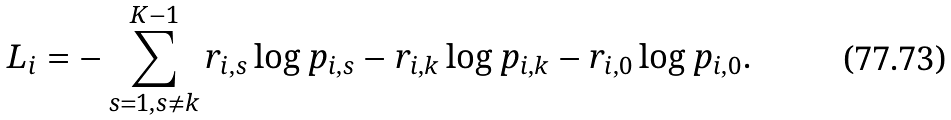<formula> <loc_0><loc_0><loc_500><loc_500>& L _ { i } = - \sum _ { s = 1 , s \neq k } ^ { K - 1 } r _ { i , s } \log p _ { i , s } - r _ { i , k } \log p _ { i , k } - r _ { i , 0 } \log p _ { i , 0 } .</formula> 